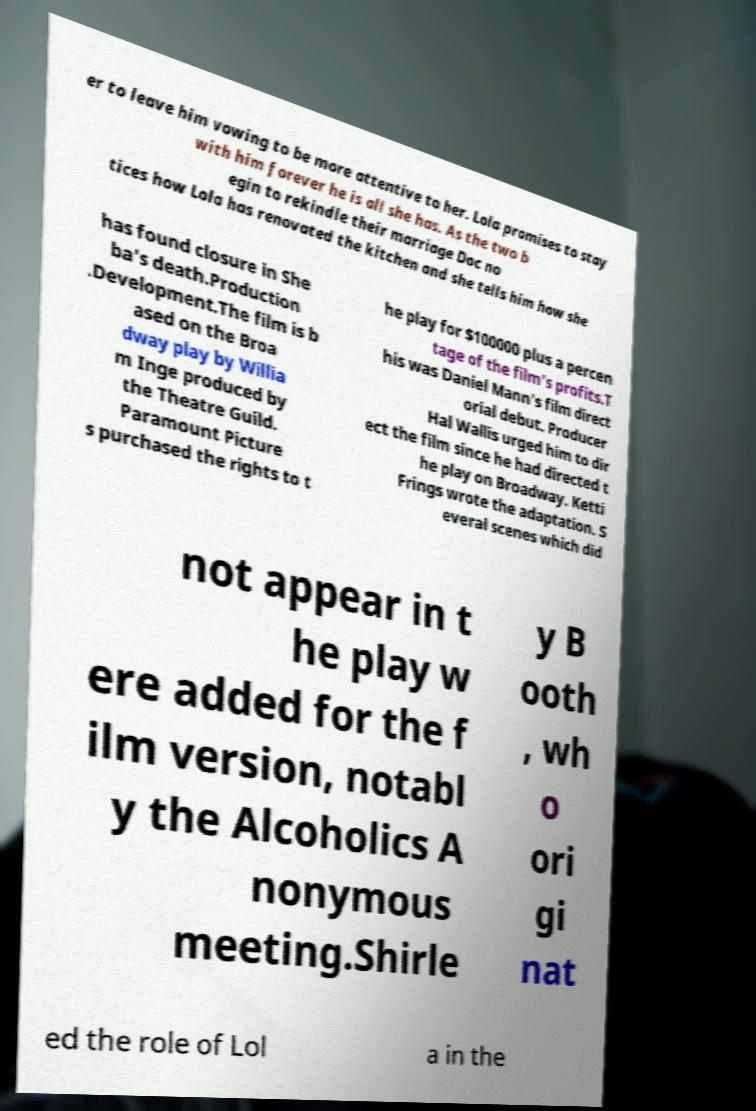Can you accurately transcribe the text from the provided image for me? er to leave him vowing to be more attentive to her. Lola promises to stay with him forever he is all she has. As the two b egin to rekindle their marriage Doc no tices how Lola has renovated the kitchen and she tells him how she has found closure in She ba's death.Production .Development.The film is b ased on the Broa dway play by Willia m Inge produced by the Theatre Guild. Paramount Picture s purchased the rights to t he play for $100000 plus a percen tage of the film's profits.T his was Daniel Mann's film direct orial debut. Producer Hal Wallis urged him to dir ect the film since he had directed t he play on Broadway. Ketti Frings wrote the adaptation. S everal scenes which did not appear in t he play w ere added for the f ilm version, notabl y the Alcoholics A nonymous meeting.Shirle y B ooth , wh o ori gi nat ed the role of Lol a in the 